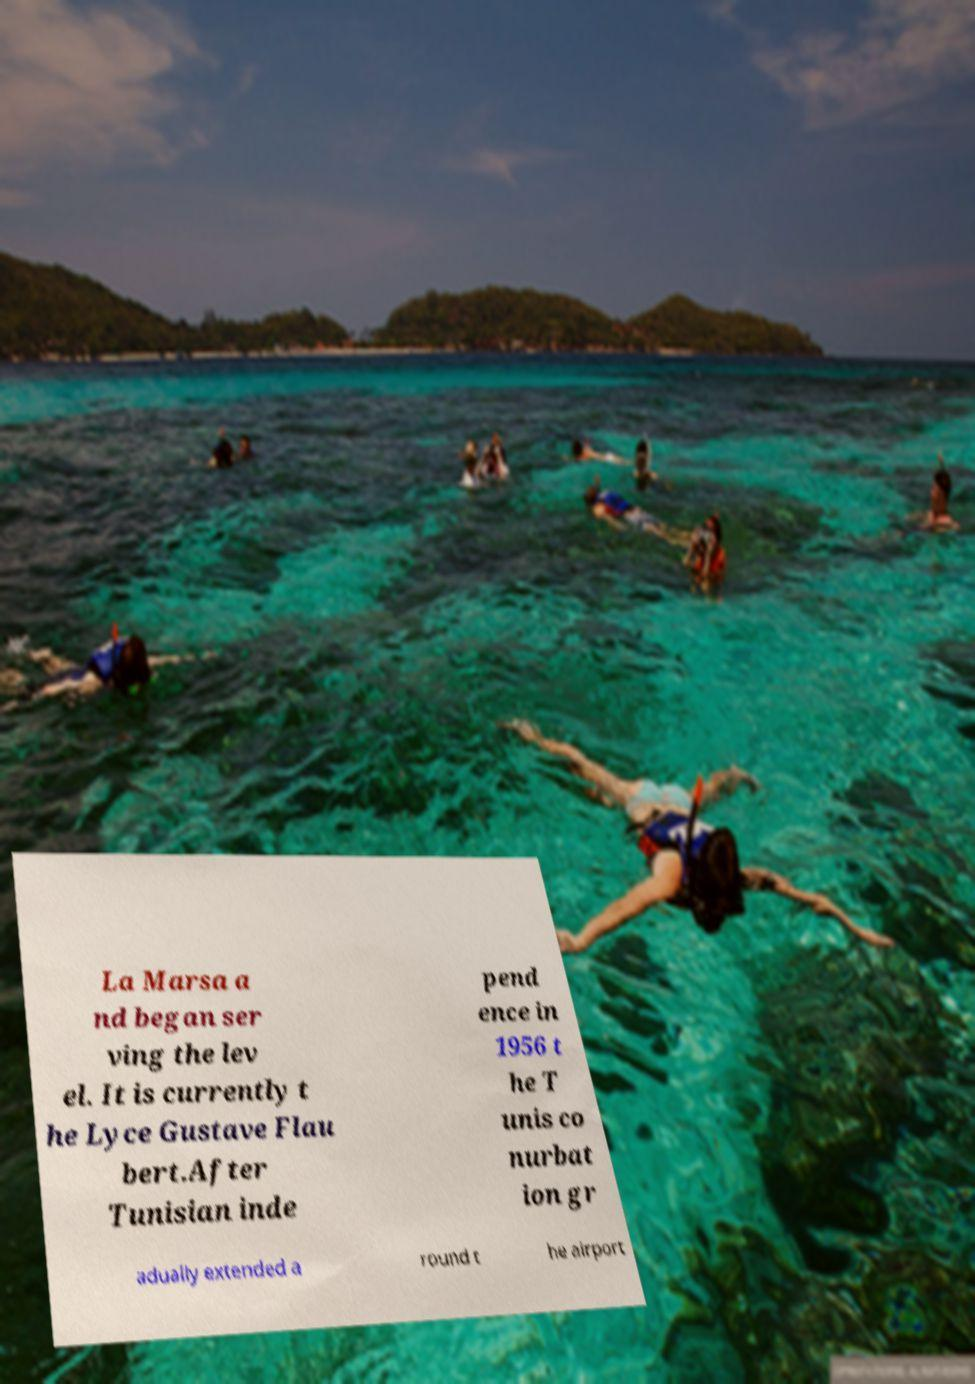Could you extract and type out the text from this image? La Marsa a nd began ser ving the lev el. It is currently t he Lyce Gustave Flau bert.After Tunisian inde pend ence in 1956 t he T unis co nurbat ion gr adually extended a round t he airport 